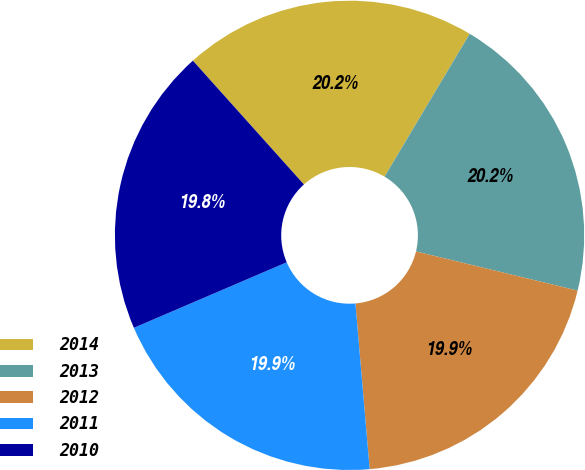Convert chart. <chart><loc_0><loc_0><loc_500><loc_500><pie_chart><fcel>2014<fcel>2013<fcel>2012<fcel>2011<fcel>2010<nl><fcel>20.19%<fcel>20.23%<fcel>19.85%<fcel>19.92%<fcel>19.81%<nl></chart> 